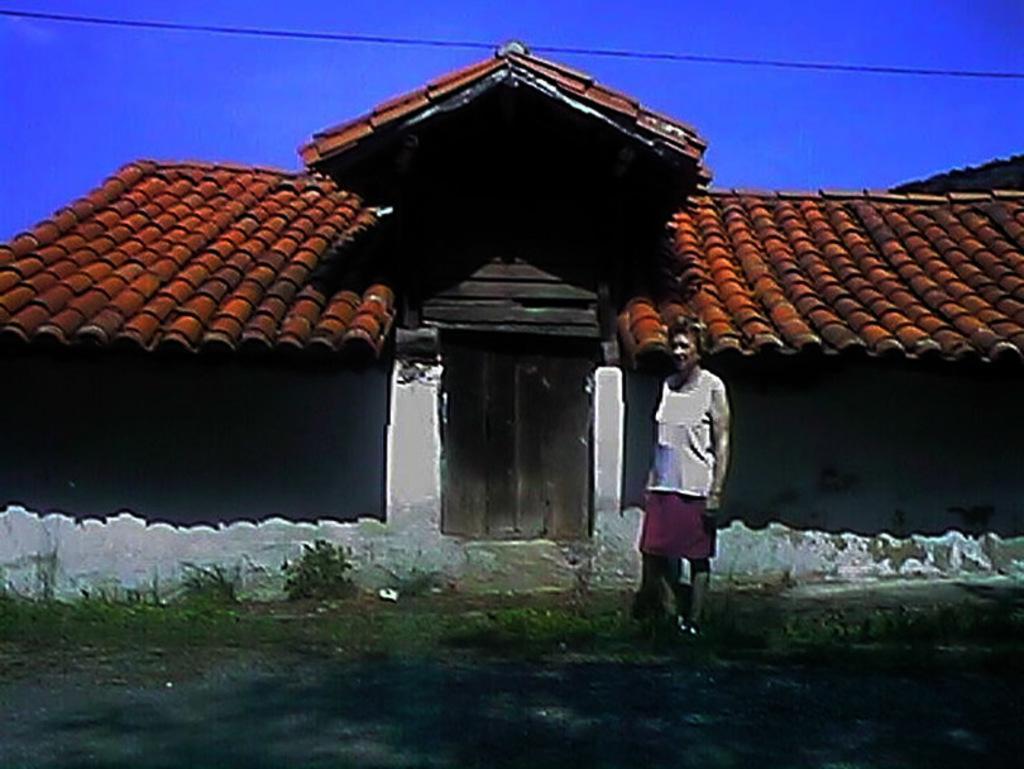In one or two sentences, can you explain what this image depicts? In this image I can see a person is standing. In the background I can see a house, plants, a wire and the sky. 